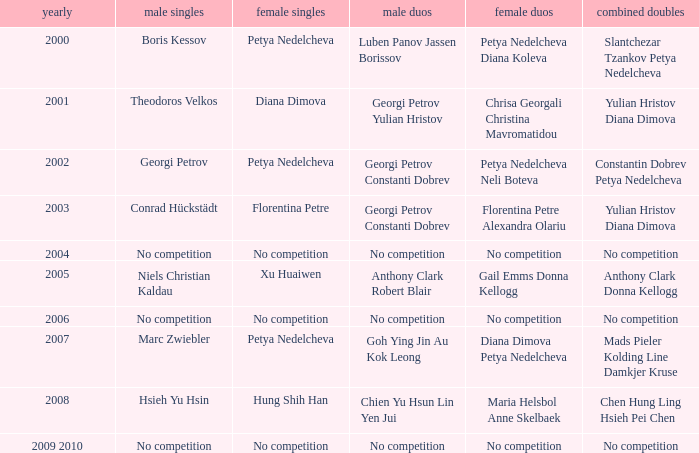Who triumphed in the men's double the same year florentina petre claimed victory in the women's singles? Georgi Petrov Constanti Dobrev. 